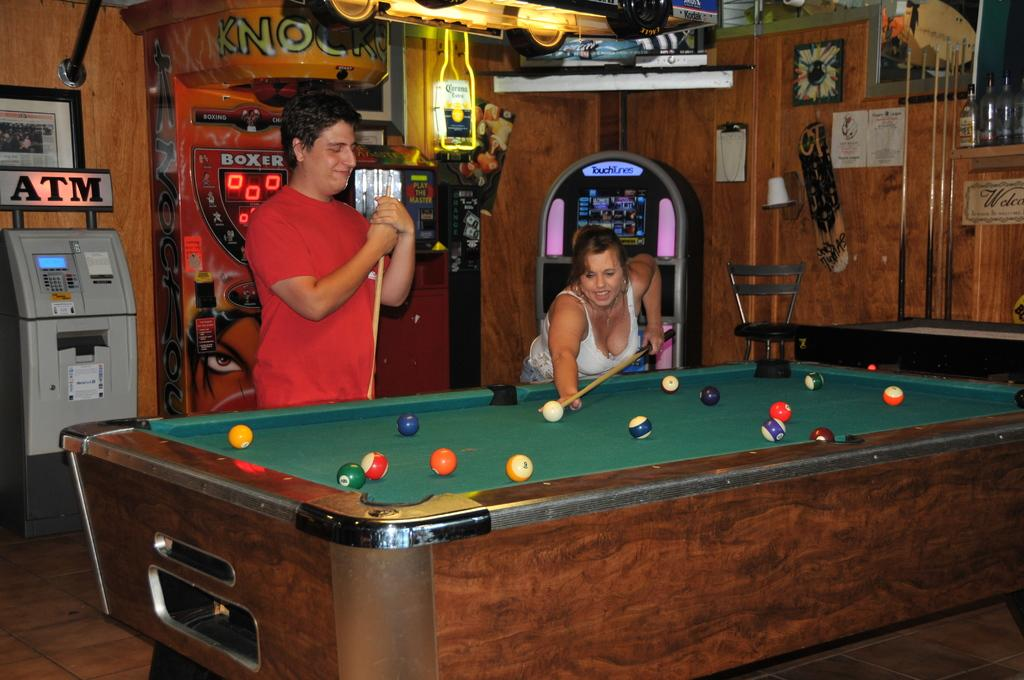How many people are in the room in the image? There are two people in the room. What are the people doing in the image? The people are playing a billiards game. What can be seen in the background of the image? There is an ATM and other games visible in the background. Is there any furniture in the room? Yes, there is a chair in the room. Can you see a horse or a giraffe in the image? No, there are no horses or giraffes present in the image. Is there a branch visible in the image? There is no branch visible in the image. 